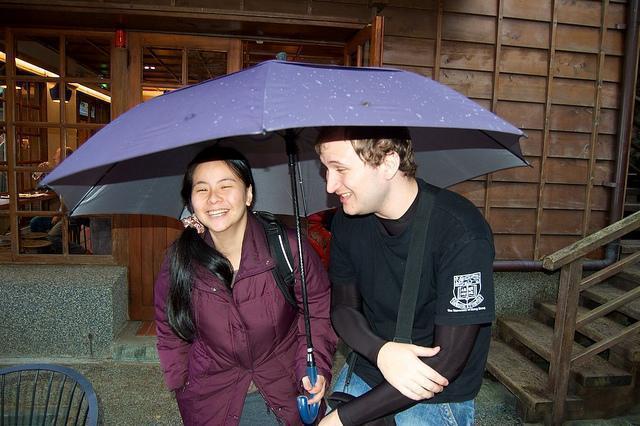What is starting here?
Make your selection from the four choices given to correctly answer the question.
Options: Snow, fight, rain, sleet. Rain. 